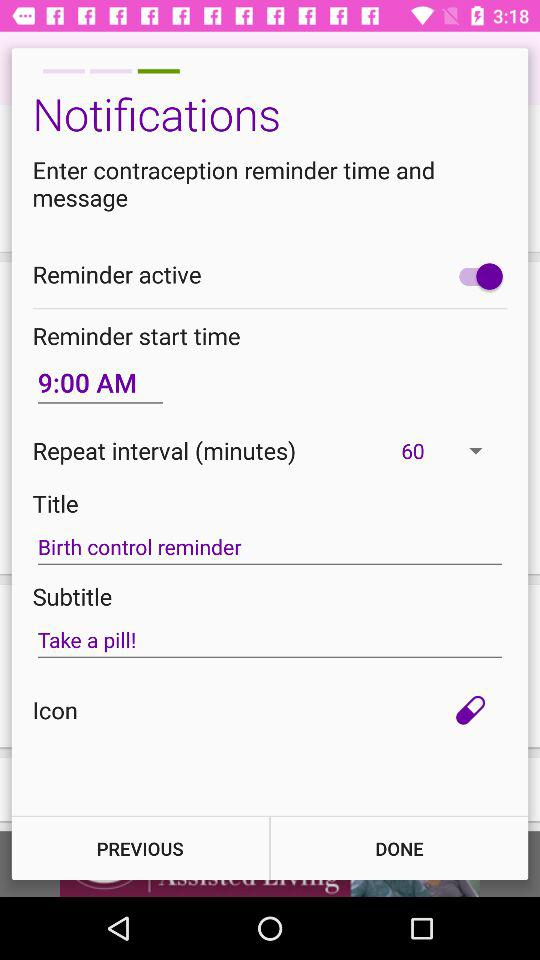What is the repeat interval? The repeat interval is 60 minutes. 